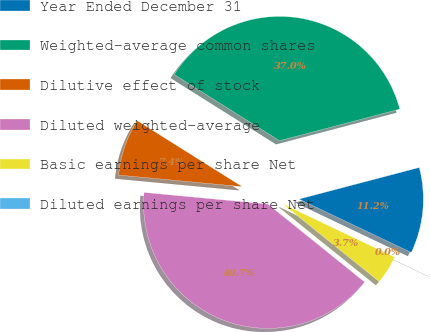Convert chart. <chart><loc_0><loc_0><loc_500><loc_500><pie_chart><fcel>Year Ended December 31<fcel>Weighted-average common shares<fcel>Dilutive effect of stock<fcel>Diluted weighted-average<fcel>Basic earnings per share Net<fcel>Diluted earnings per share Net<nl><fcel>11.16%<fcel>36.98%<fcel>7.44%<fcel>40.7%<fcel>3.72%<fcel>0.0%<nl></chart> 